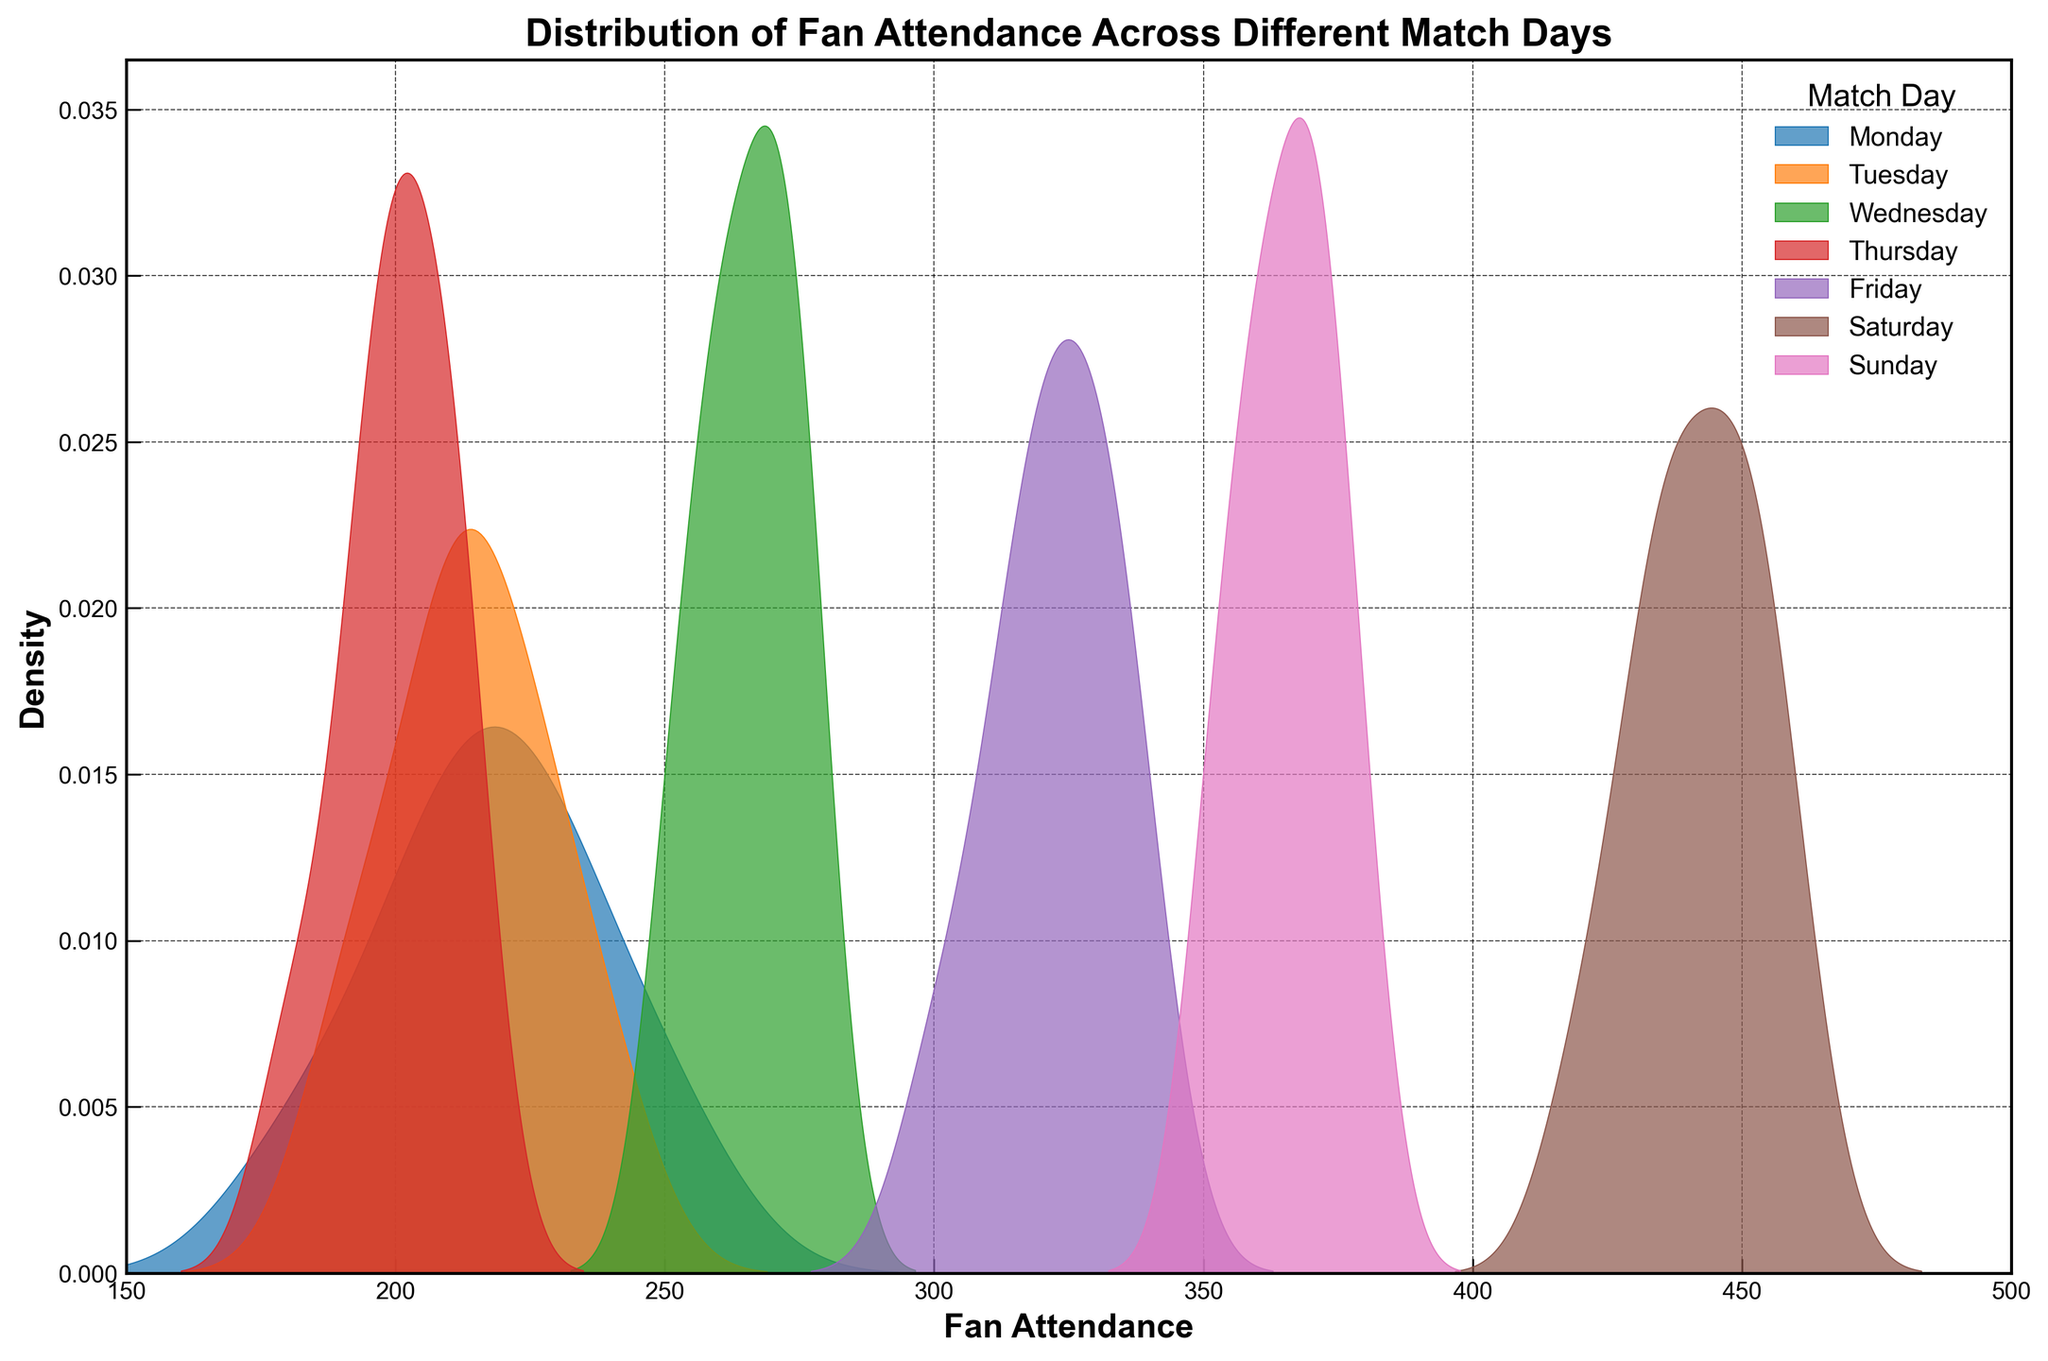What does the title of the plot indicate? The title of the plot states 'Distribution of Fan Attendance Across Different Match Days', indicating that the plot shows how fan attendance differs across various days of the week.
Answer: Distribution of Fan Attendance Across Different Match Days What is the range of fan attendance values shown on the x-axis? The x-axis is labeled ‘Fan Attendance’ and ranges from 150 to 500, representing the different possible attendance numbers across all match days.
Answer: 150 to 500 Which match day has the highest peak in density for fan attendance? Saturday's curve is the highest, indicating the highest density of fan attendance on this day.
Answer: Saturday Which match day has the lowest fan attendance density? The density curve for Thursday is the lowest, which corresponds to the lowest density of fan attendance compared to other days.
Answer: Thursday How does the fan attendance on Friday compare to that on Wednesday? Friday's density curve is shifted to the right of Wednesday's, indicating higher attendance on Friday compared to Wednesday.
Answer: Friday has higher attendance What is the approximate peak attendance on Sunday based on the plot? The density peak for Sunday appears around 360 to 370 fans. Looking at the highest point of the density curve for Sunday, the approximate peak attendance is in this range.
Answer: 360 to 370 fans How does fan attendance on Monday compare to Tuesday? The density plots for Monday and Tuesday are quite similar with slight variations, but both days have peaks around the 200 to 230 fan attendance mark, suggesting similar attendance levels.
Answer: Similar attendance levels What is the general trend in attendance from Monday to Sunday? Observing the density curves, there is an increasing trend in fan attendance from Monday to Saturday, with Sunday being slightly lower than Saturday but still higher than the other weekdays.
Answer: Increasing trend from Monday to Saturday Which days have multiple peaks in their density plots? Both Wednesday and Friday show a clear bimodal distribution with two peaks in their density plots, indicating variability in fan attendance on these days.
Answer: Wednesday and Friday What is the fan attendance range for which Saturday has the highest density? Saturday's highest density appears between approximately 430 and 450 fans, where the density curve reaches its highest point.
Answer: 430 to 450 fans 